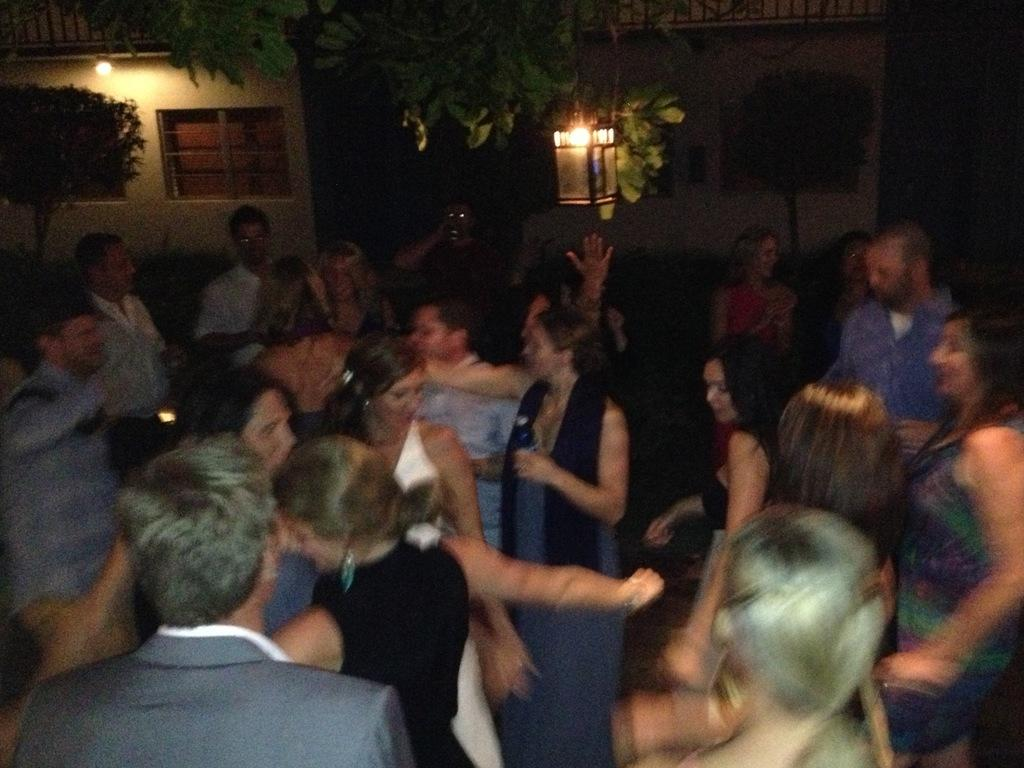How many people are in the image? There is a group of people in the image. What can be seen in the background of the image? There are houses, trees, lights, and other unspecified objects in the background of the image. How many dolls are sitting with the group of people in the image? There are no dolls present in the image. What type of cat can be seen playing with the group of people in the image? There are no cats present in the image. 